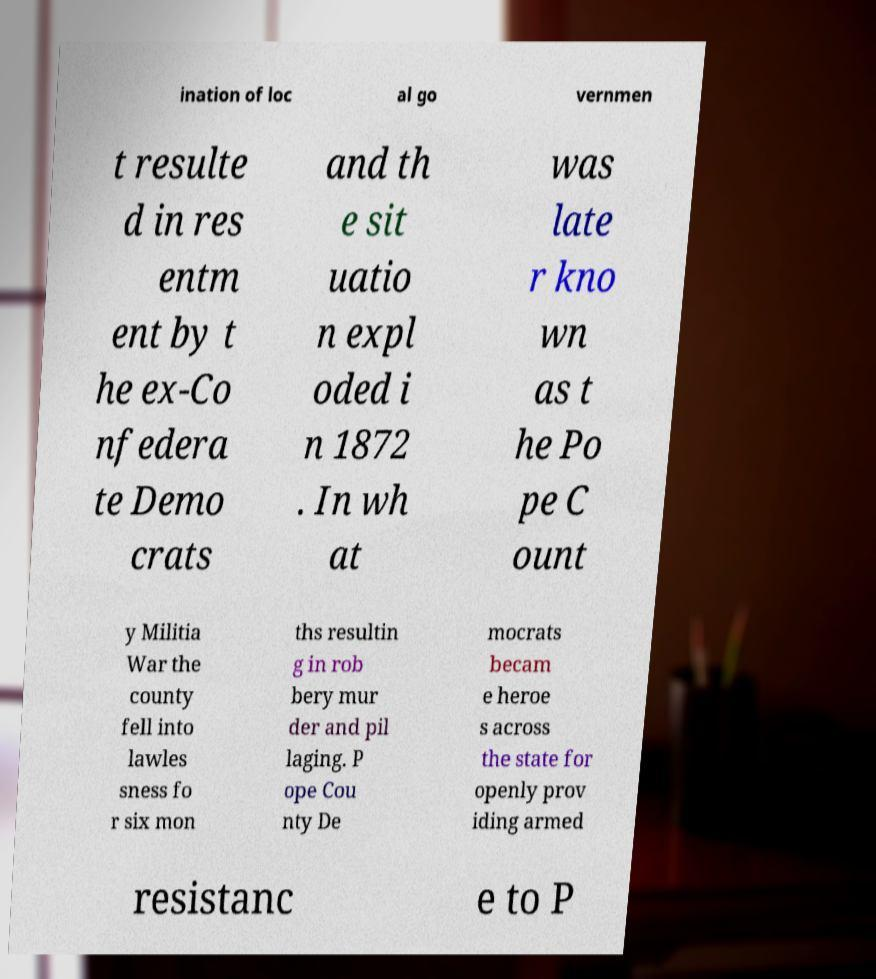What messages or text are displayed in this image? I need them in a readable, typed format. ination of loc al go vernmen t resulte d in res entm ent by t he ex-Co nfedera te Demo crats and th e sit uatio n expl oded i n 1872 . In wh at was late r kno wn as t he Po pe C ount y Militia War the county fell into lawles sness fo r six mon ths resultin g in rob bery mur der and pil laging. P ope Cou nty De mocrats becam e heroe s across the state for openly prov iding armed resistanc e to P 